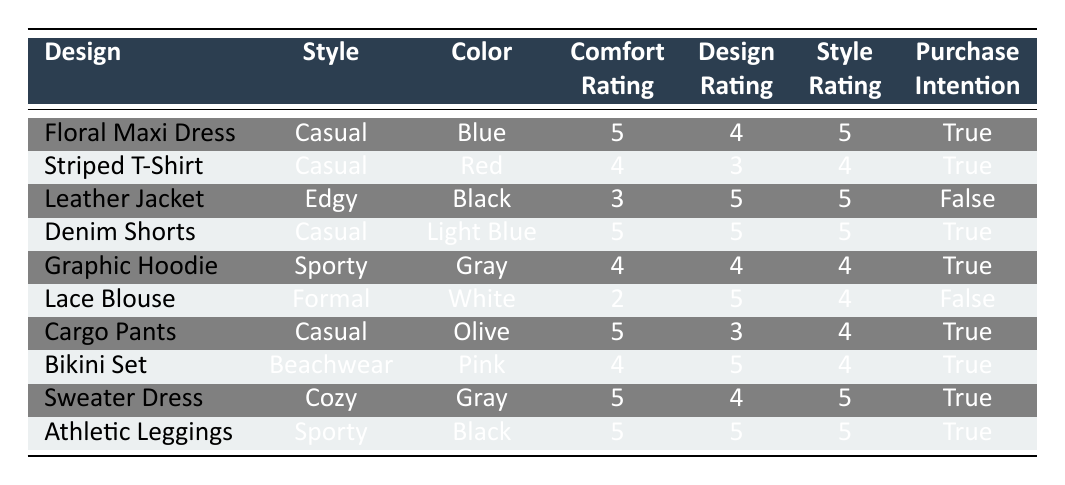What is the design of the product with the highest comfort rating? The highest comfort rating in the table is 5, which is achieved by several products. However, the first occurrence is for the "Floral Maxi Dress."
Answer: Floral Maxi Dress Which product has a purchase intention of false? By scanning the table, the product with a purchase intention marked as false is the "Leather Jacket" and "Lace Blouse." I will highlight the first occurrence.
Answer: Leather Jacket What is the average design rating of the casual style products? There are four casual style products: "Floral Maxi Dress," "Striped T-Shirt," "Denim Shorts," and "Cargo Pants." Their design ratings are 4, 3, 5, and 3 respectively. The average is calculated as (4 + 3 + 5 + 3) / 4 = 15 / 4 = 3.75.
Answer: 3.75 Are all sporty style products rated highly in comfort with a score of 4 or above? The sporty style products in the table are the "Graphic Hoodie" and "Athletic Leggings." "Graphic Hoodie" has a comfort rating of 4, and "Athletic Leggings" has a comfort rating of 5. Both are rated 4 or above, so the answer is yes.
Answer: Yes Which product has the best overall ratings (comfort, design, style) in the table? To identify the product with the best overall ratings, we sum the comfort, design, and style ratings for each product. The highest total ratings are for the "Athletic Leggings," with a sum of 5 + 5 + 5 = 15.
Answer: Athletic Leggings 